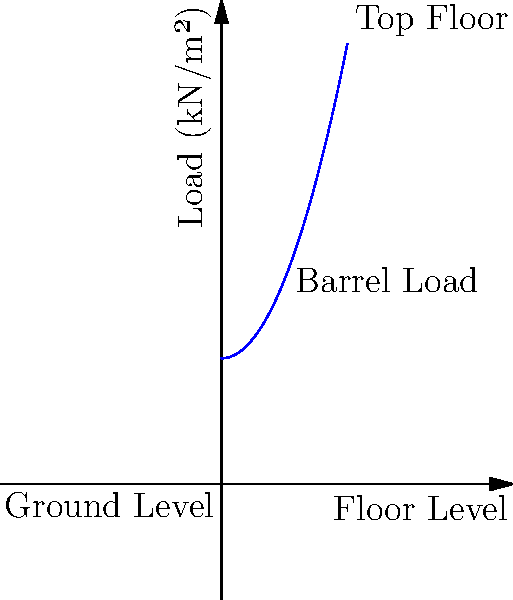In your aging multi-story warehouse, the structural load from barrels increases quadratically with floor height due to innovative stacking techniques. If the ground floor load is 5 kN/m² and the load at the top floor (5th level) is 17.5 kN/m², what is the total load on the 3rd floor? Assume the load distribution follows the function $L(x) = ax^2 + b$, where $x$ is the floor level (0-5) and $L$ is the load in kN/m². To solve this problem, we'll follow these steps:

1) First, we need to determine the coefficients $a$ and $b$ in the quadratic function $L(x) = ax^2 + b$.

2) We know two points on this curve:
   - At $x = 0$ (ground floor), $L(0) = 5$ kN/m²
   - At $x = 5$ (top floor), $L(5) = 17.5$ kN/m²

3) Using these points, we can set up two equations:
   $5 = b$ (ground floor)
   $17.5 = 25a + 5$ (top floor)

4) From the first equation, we know that $b = 5$.

5) Substituting this into the second equation:
   $17.5 = 25a + 5$
   $12.5 = 25a$
   $a = 0.5$

6) So our load function is $L(x) = 0.5x^2 + 5$

7) For the 3rd floor, $x = 3$. Let's calculate $L(3)$:
   $L(3) = 0.5(3^2) + 5 = 0.5(9) + 5 = 4.5 + 5 = 9.5$

Therefore, the load on the 3rd floor is 9.5 kN/m².
Answer: 9.5 kN/m² 